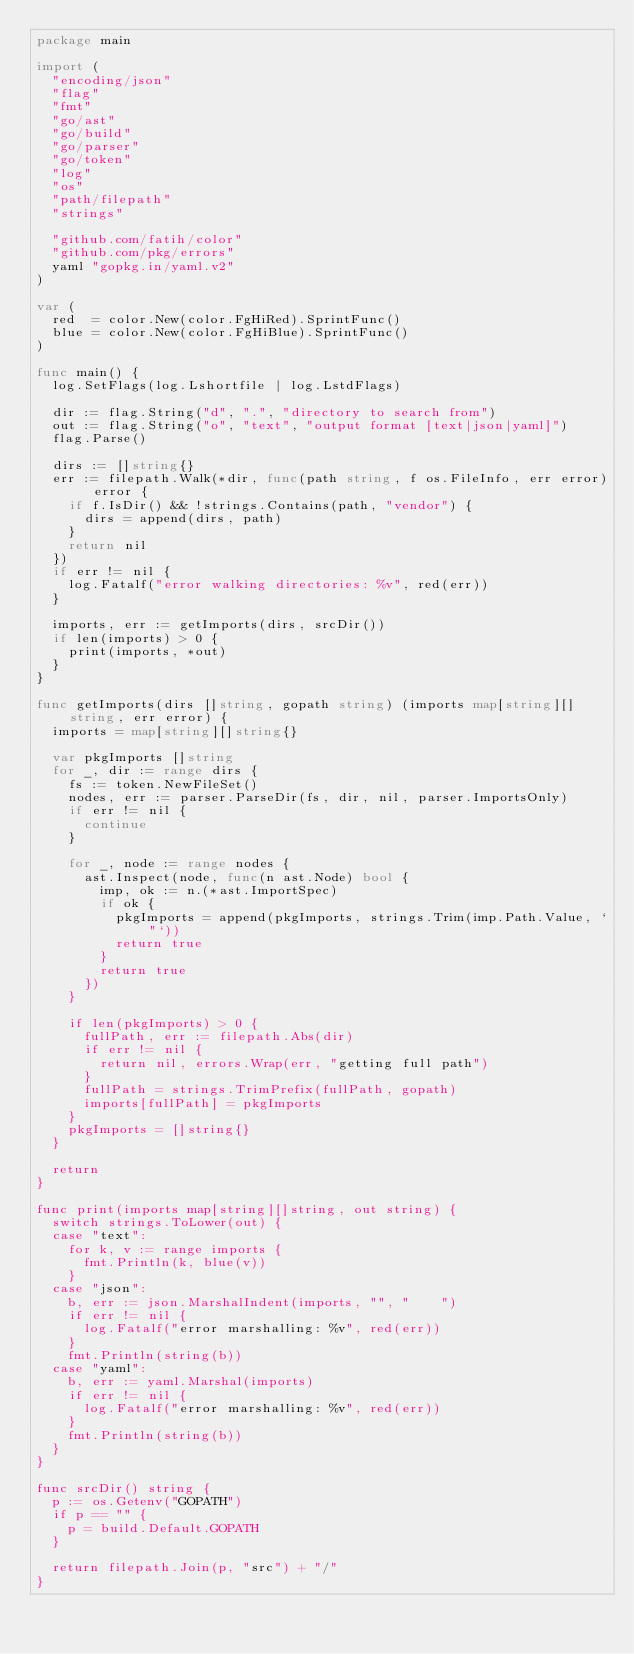<code> <loc_0><loc_0><loc_500><loc_500><_Go_>package main

import (
	"encoding/json"
	"flag"
	"fmt"
	"go/ast"
	"go/build"
	"go/parser"
	"go/token"
	"log"
	"os"
	"path/filepath"
	"strings"

	"github.com/fatih/color"
	"github.com/pkg/errors"
	yaml "gopkg.in/yaml.v2"
)

var (
	red  = color.New(color.FgHiRed).SprintFunc()
	blue = color.New(color.FgHiBlue).SprintFunc()
)

func main() {
	log.SetFlags(log.Lshortfile | log.LstdFlags)

	dir := flag.String("d", ".", "directory to search from")
	out := flag.String("o", "text", "output format [text|json|yaml]")
	flag.Parse()

	dirs := []string{}
	err := filepath.Walk(*dir, func(path string, f os.FileInfo, err error) error {
		if f.IsDir() && !strings.Contains(path, "vendor") {
			dirs = append(dirs, path)
		}
		return nil
	})
	if err != nil {
		log.Fatalf("error walking directories: %v", red(err))
	}

	imports, err := getImports(dirs, srcDir())
	if len(imports) > 0 {
		print(imports, *out)
	}
}

func getImports(dirs []string, gopath string) (imports map[string][]string, err error) {
	imports = map[string][]string{}

	var pkgImports []string
	for _, dir := range dirs {
		fs := token.NewFileSet()
		nodes, err := parser.ParseDir(fs, dir, nil, parser.ImportsOnly)
		if err != nil {
			continue
		}

		for _, node := range nodes {
			ast.Inspect(node, func(n ast.Node) bool {
				imp, ok := n.(*ast.ImportSpec)
				if ok {
					pkgImports = append(pkgImports, strings.Trim(imp.Path.Value, `"`))
					return true
				}
				return true
			})
		}

		if len(pkgImports) > 0 {
			fullPath, err := filepath.Abs(dir)
			if err != nil {
				return nil, errors.Wrap(err, "getting full path")
			}
			fullPath = strings.TrimPrefix(fullPath, gopath)
			imports[fullPath] = pkgImports
		}
		pkgImports = []string{}
	}

	return
}

func print(imports map[string][]string, out string) {
	switch strings.ToLower(out) {
	case "text":
		for k, v := range imports {
			fmt.Println(k, blue(v))
		}
	case "json":
		b, err := json.MarshalIndent(imports, "", "    ")
		if err != nil {
			log.Fatalf("error marshalling: %v", red(err))
		}
		fmt.Println(string(b))
	case "yaml":
		b, err := yaml.Marshal(imports)
		if err != nil {
			log.Fatalf("error marshalling: %v", red(err))
		}
		fmt.Println(string(b))
	}
}

func srcDir() string {
	p := os.Getenv("GOPATH")
	if p == "" {
		p = build.Default.GOPATH
	}

	return filepath.Join(p, "src") + "/"
}
</code> 